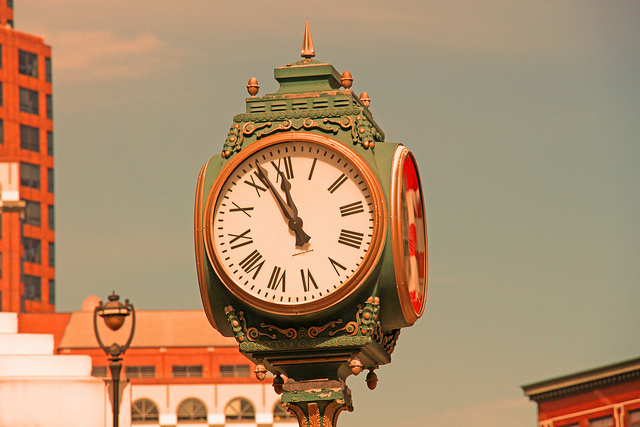Extract all visible text content from this image. XI I XI VII v III 